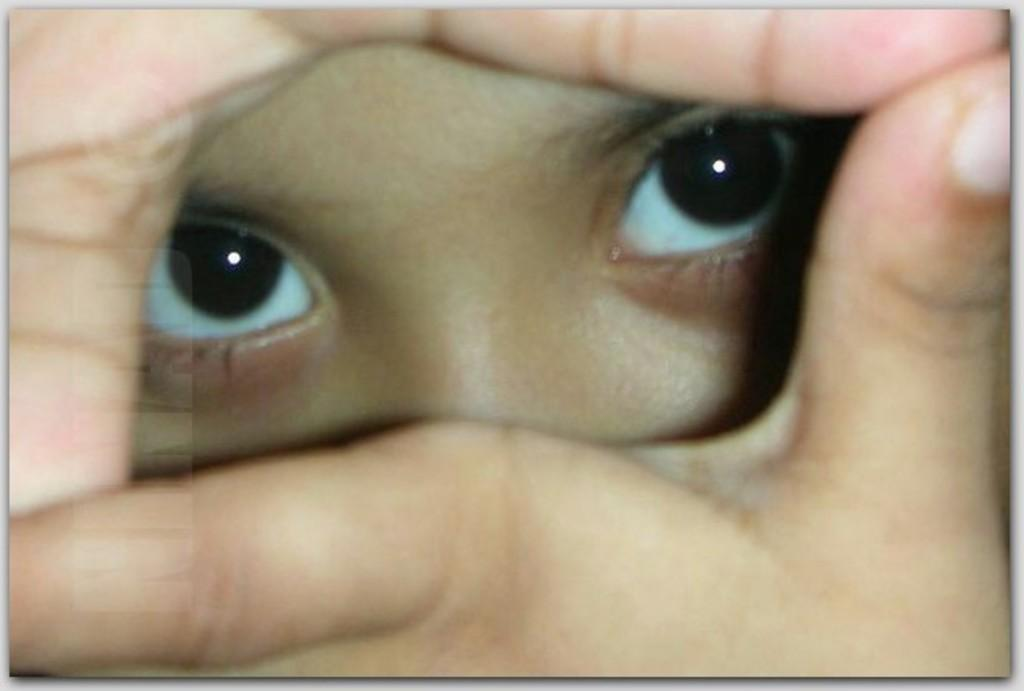What body parts of a person are visible in the image? The image contains a person's eyes and fingers. Can you describe the eyes in the image? The image only shows the person's eyes, so it's not possible to provide a detailed description. What type of toad can be seen sitting on the crate in the image? There is no toad or crate present in the image; it only contains a person's eyes and fingers. Is the person holding a gun in the image? There is no gun present in the image; it only contains a person's eyes and fingers. 